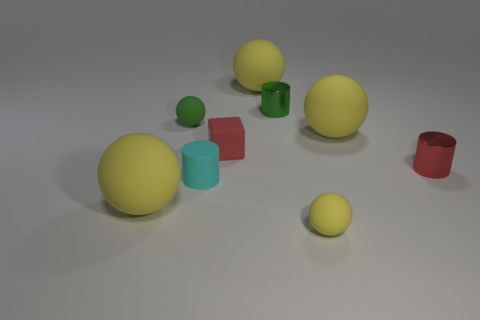Are there fewer large yellow spheres behind the cube than yellow rubber balls that are in front of the small green ball?
Provide a short and direct response. Yes. What number of other objects are there of the same size as the matte cube?
Keep it short and to the point. 5. What is the shape of the tiny red thing that is on the left side of the tiny rubber object in front of the large matte sphere on the left side of the red matte object?
Ensure brevity in your answer.  Cube. How many yellow objects are either spheres or big things?
Offer a very short reply. 4. There is a matte sphere right of the tiny yellow sphere; what number of tiny red rubber blocks are behind it?
Your answer should be very brief. 0. Is there anything else of the same color as the matte block?
Give a very brief answer. Yes. What is the shape of the red object that is the same material as the cyan cylinder?
Keep it short and to the point. Cube. Are the green thing to the right of the small green matte ball and the small cyan thing to the right of the small green rubber object made of the same material?
Give a very brief answer. No. How many objects are either cubes or yellow rubber spheres behind the small yellow rubber ball?
Provide a succinct answer. 4. What is the shape of the tiny object that is the same color as the small block?
Make the answer very short. Cylinder. 